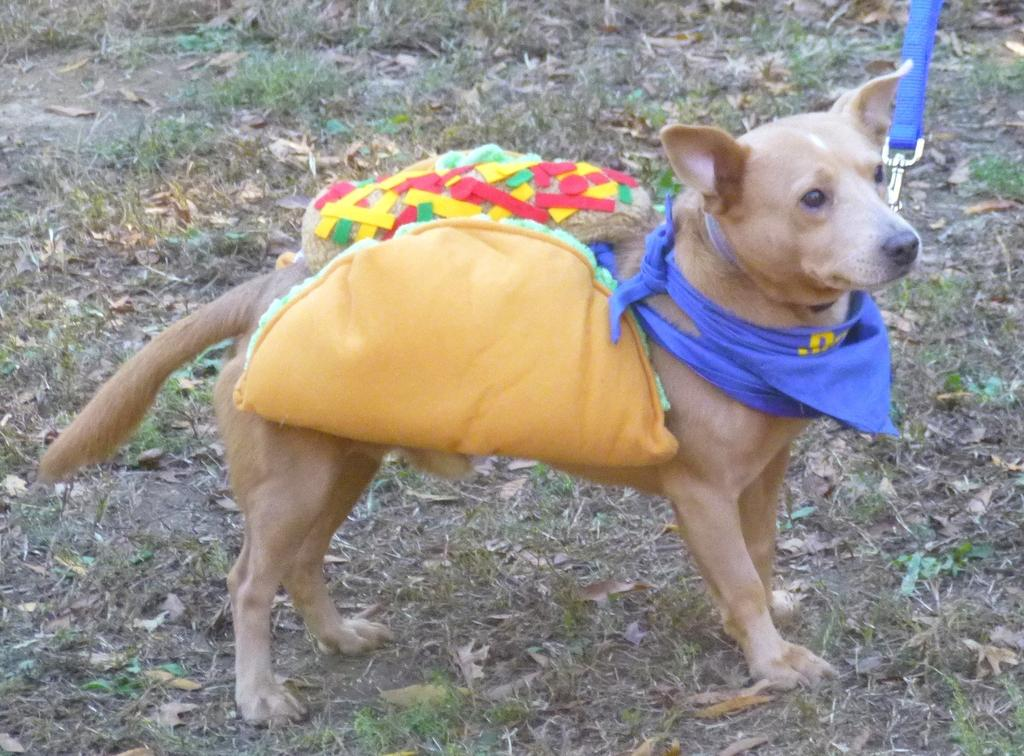What animal is present in the image? There is a dog in the image. Where is the dog positioned in the image? The dog is standing in the front. What is the dog doing in the image? The dog is carrying clothes. What is attached to the dog's neck? There is a strap on the dog's neck. What type of natural environment is visible at the bottom of the image? Leaves and grass are visible at the bottom of the image. What type of sign can be seen in the image? There is no sign present in the image. What type of fowl is visible in the image? There is no fowl present in the image. 